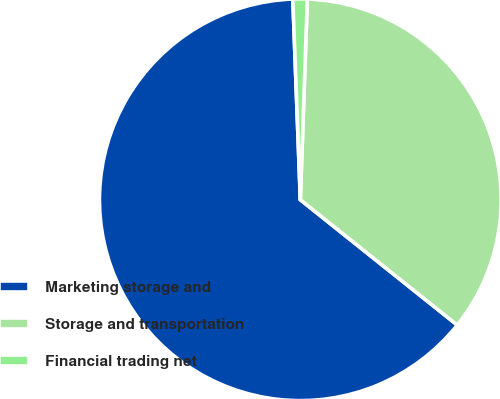Convert chart to OTSL. <chart><loc_0><loc_0><loc_500><loc_500><pie_chart><fcel>Marketing storage and<fcel>Storage and transportation<fcel>Financial trading net<nl><fcel>63.68%<fcel>35.17%<fcel>1.15%<nl></chart> 